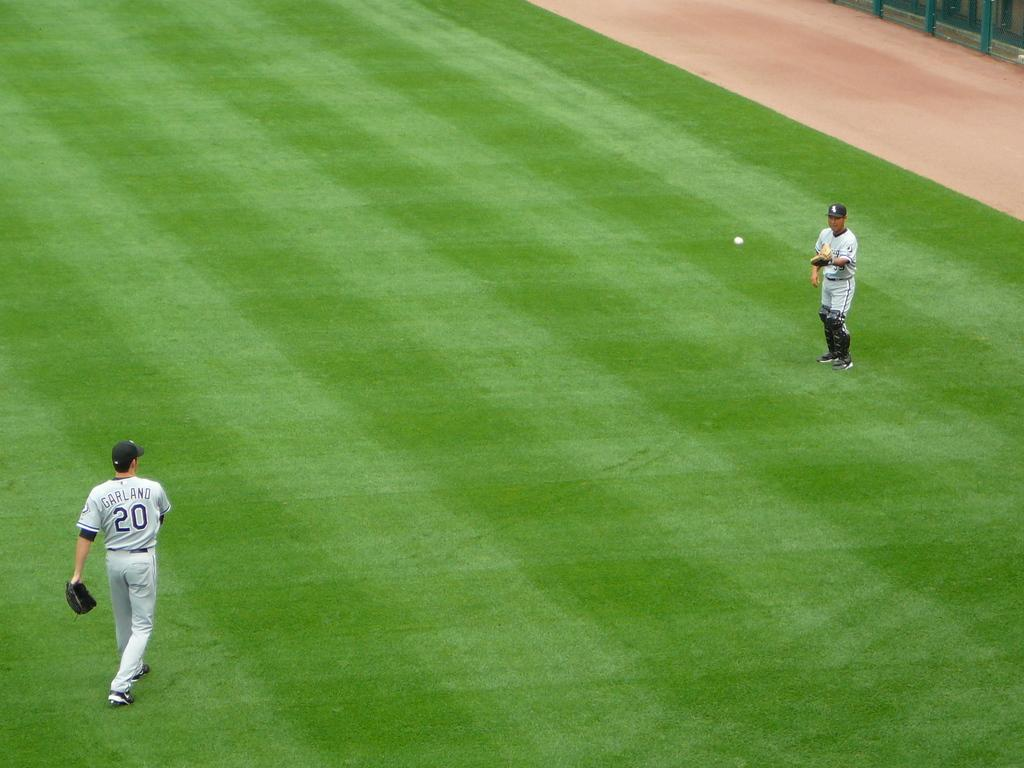<image>
Relay a brief, clear account of the picture shown. two baseball players throwing a ball, one of whom is wearing a number 20 jersey 